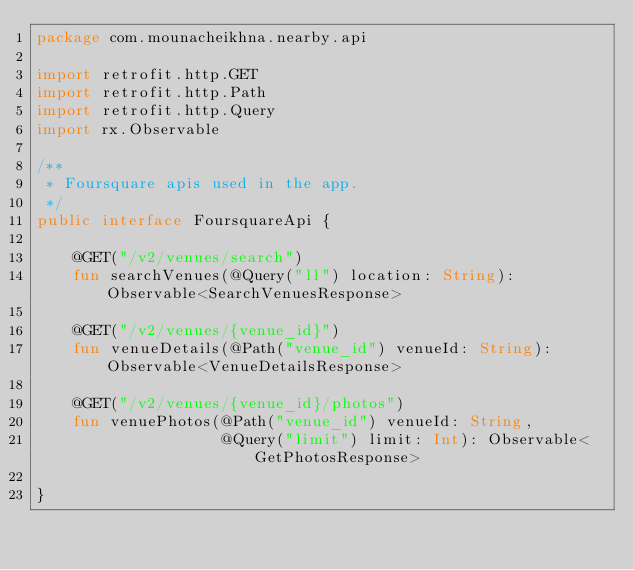Convert code to text. <code><loc_0><loc_0><loc_500><loc_500><_Kotlin_>package com.mounacheikhna.nearby.api

import retrofit.http.GET
import retrofit.http.Path
import retrofit.http.Query
import rx.Observable

/**
 * Foursquare apis used in the app.
 */
public interface FoursquareApi {

    @GET("/v2/venues/search")
    fun searchVenues(@Query("ll") location: String): Observable<SearchVenuesResponse>

    @GET("/v2/venues/{venue_id}")
    fun venueDetails(@Path("venue_id") venueId: String): Observable<VenueDetailsResponse>

    @GET("/v2/venues/{venue_id}/photos")
    fun venuePhotos(@Path("venue_id") venueId: String,
                    @Query("limit") limit: Int): Observable<GetPhotosResponse>

}</code> 